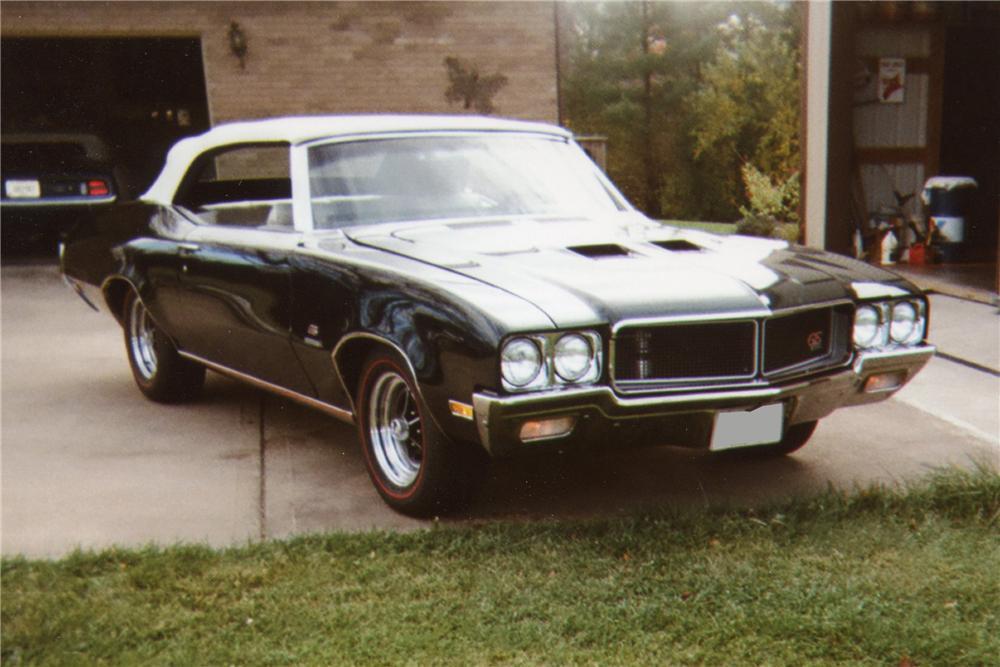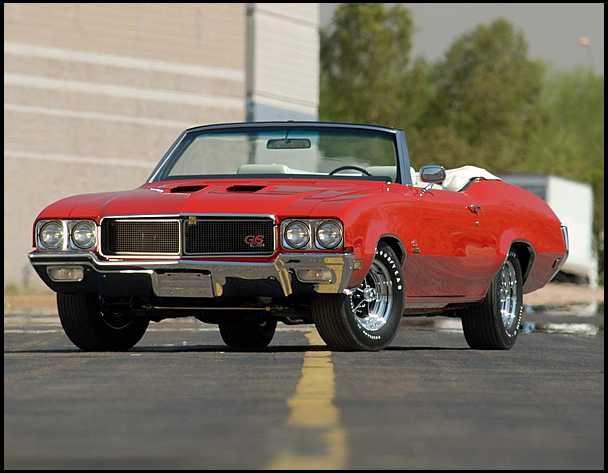The first image is the image on the left, the second image is the image on the right. Examine the images to the left and right. Is the description "The image on the right contains a red convertible." accurate? Answer yes or no. Yes. 